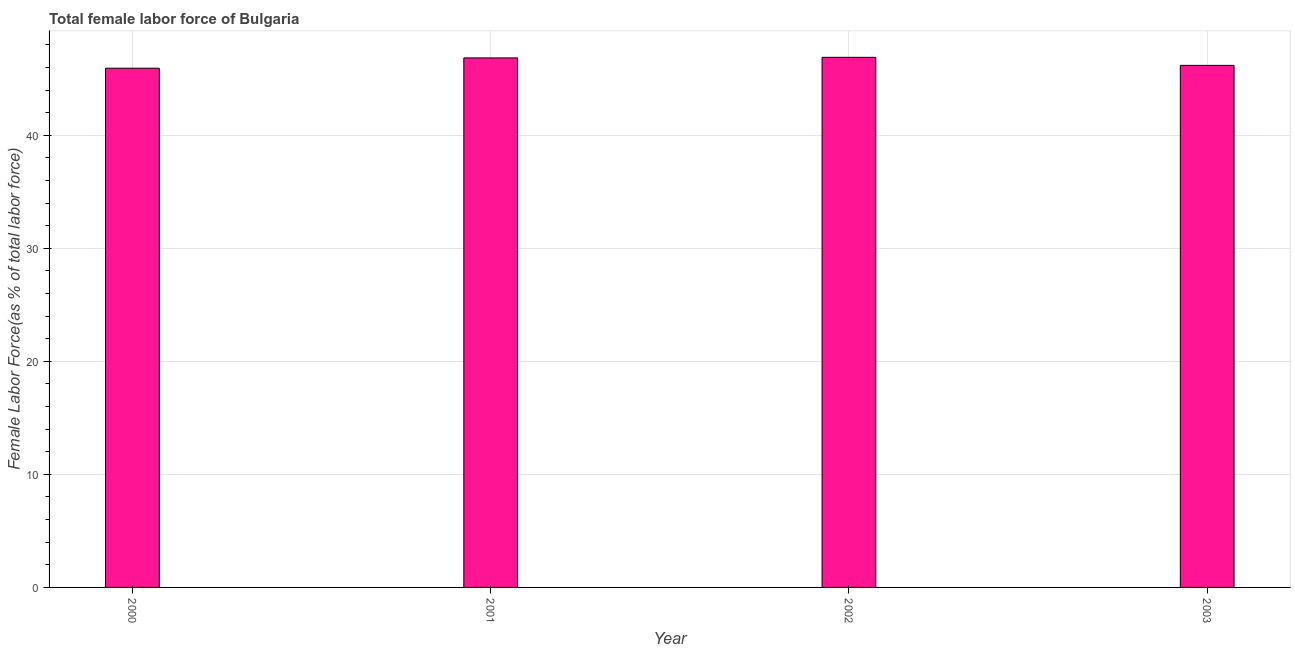Does the graph contain grids?
Make the answer very short. Yes. What is the title of the graph?
Your response must be concise. Total female labor force of Bulgaria. What is the label or title of the Y-axis?
Offer a terse response. Female Labor Force(as % of total labor force). What is the total female labor force in 2002?
Keep it short and to the point. 46.89. Across all years, what is the maximum total female labor force?
Offer a very short reply. 46.89. Across all years, what is the minimum total female labor force?
Offer a terse response. 45.93. In which year was the total female labor force minimum?
Keep it short and to the point. 2000. What is the sum of the total female labor force?
Your response must be concise. 185.85. What is the difference between the total female labor force in 2002 and 2003?
Offer a terse response. 0.71. What is the average total female labor force per year?
Offer a very short reply. 46.46. What is the median total female labor force?
Your response must be concise. 46.51. What is the ratio of the total female labor force in 2002 to that in 2003?
Provide a succinct answer. 1.01. Is the total female labor force in 2000 less than that in 2002?
Offer a very short reply. Yes. Is the difference between the total female labor force in 2001 and 2003 greater than the difference between any two years?
Provide a short and direct response. No. What is the difference between the highest and the second highest total female labor force?
Keep it short and to the point. 0.05. Is the sum of the total female labor force in 2002 and 2003 greater than the maximum total female labor force across all years?
Ensure brevity in your answer.  Yes. What is the difference between the highest and the lowest total female labor force?
Your answer should be very brief. 0.96. How many bars are there?
Offer a terse response. 4. How many years are there in the graph?
Keep it short and to the point. 4. What is the difference between two consecutive major ticks on the Y-axis?
Your answer should be very brief. 10. Are the values on the major ticks of Y-axis written in scientific E-notation?
Your answer should be compact. No. What is the Female Labor Force(as % of total labor force) of 2000?
Your response must be concise. 45.93. What is the Female Labor Force(as % of total labor force) of 2001?
Ensure brevity in your answer.  46.84. What is the Female Labor Force(as % of total labor force) in 2002?
Provide a succinct answer. 46.89. What is the Female Labor Force(as % of total labor force) in 2003?
Offer a terse response. 46.18. What is the difference between the Female Labor Force(as % of total labor force) in 2000 and 2001?
Your response must be concise. -0.91. What is the difference between the Female Labor Force(as % of total labor force) in 2000 and 2002?
Make the answer very short. -0.96. What is the difference between the Female Labor Force(as % of total labor force) in 2000 and 2003?
Your response must be concise. -0.25. What is the difference between the Female Labor Force(as % of total labor force) in 2001 and 2002?
Ensure brevity in your answer.  -0.05. What is the difference between the Female Labor Force(as % of total labor force) in 2001 and 2003?
Your answer should be very brief. 0.66. What is the difference between the Female Labor Force(as % of total labor force) in 2002 and 2003?
Your response must be concise. 0.71. What is the ratio of the Female Labor Force(as % of total labor force) in 2000 to that in 2003?
Provide a succinct answer. 0.99. What is the ratio of the Female Labor Force(as % of total labor force) in 2001 to that in 2003?
Offer a terse response. 1.01. 